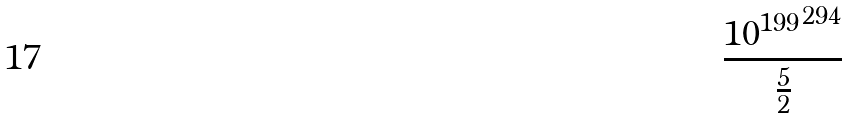<formula> <loc_0><loc_0><loc_500><loc_500>\frac { { 1 0 ^ { 1 9 9 } } ^ { 2 9 4 } } { \frac { 5 } { 2 } }</formula> 